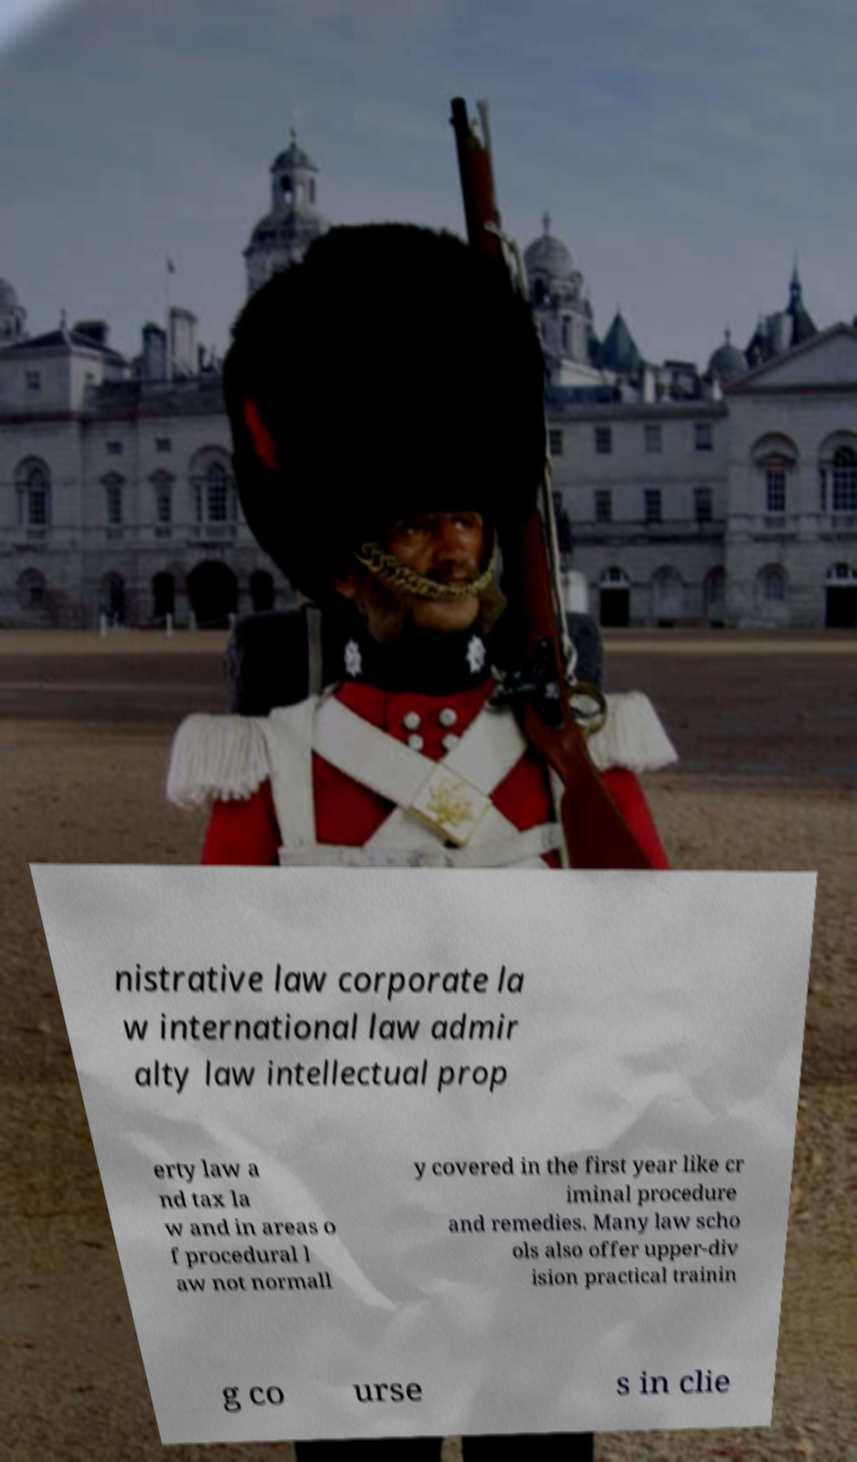For documentation purposes, I need the text within this image transcribed. Could you provide that? nistrative law corporate la w international law admir alty law intellectual prop erty law a nd tax la w and in areas o f procedural l aw not normall y covered in the first year like cr iminal procedure and remedies. Many law scho ols also offer upper-div ision practical trainin g co urse s in clie 